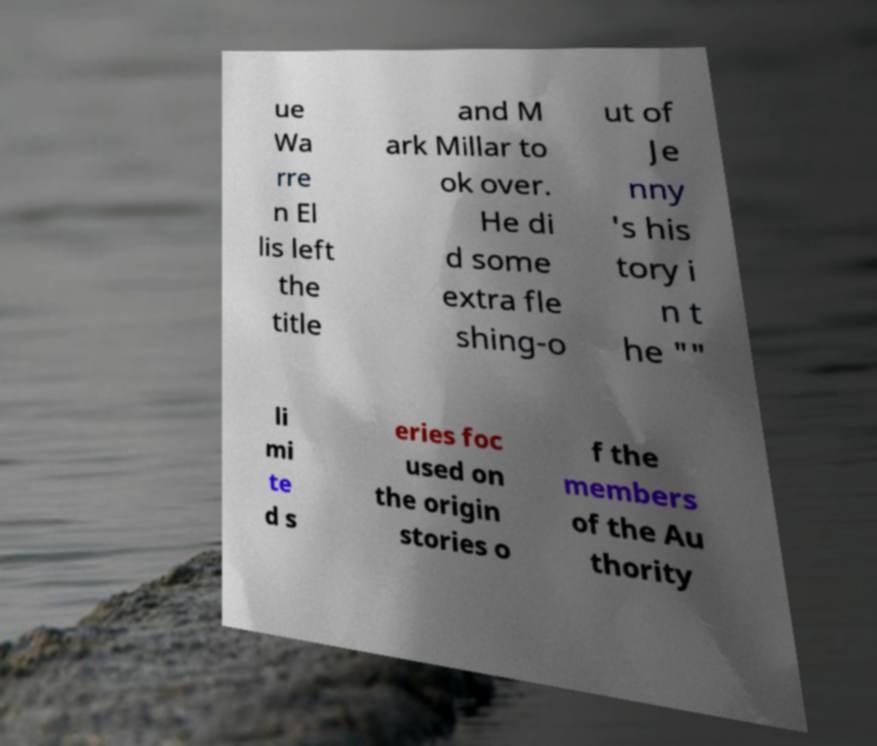I need the written content from this picture converted into text. Can you do that? ue Wa rre n El lis left the title and M ark Millar to ok over. He di d some extra fle shing-o ut of Je nny 's his tory i n t he "" li mi te d s eries foc used on the origin stories o f the members of the Au thority 